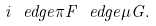<formula> <loc_0><loc_0><loc_500><loc_500>i \ e d g e { \pi } F \ e d g e { \mu } G .</formula> 